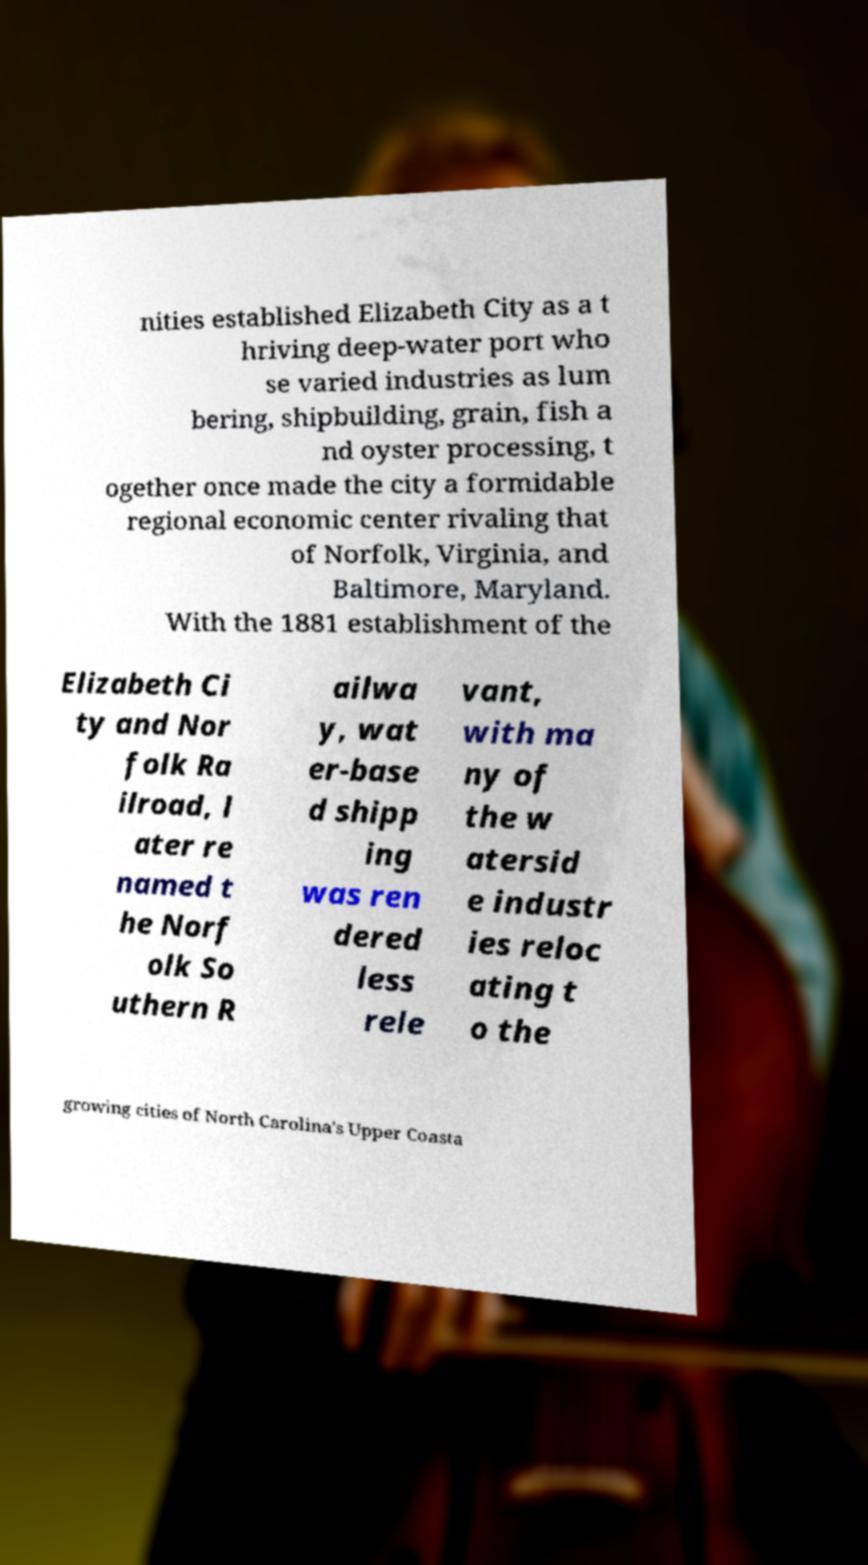Could you assist in decoding the text presented in this image and type it out clearly? nities established Elizabeth City as a t hriving deep-water port who se varied industries as lum bering, shipbuilding, grain, fish a nd oyster processing, t ogether once made the city a formidable regional economic center rivaling that of Norfolk, Virginia, and Baltimore, Maryland. With the 1881 establishment of the Elizabeth Ci ty and Nor folk Ra ilroad, l ater re named t he Norf olk So uthern R ailwa y, wat er-base d shipp ing was ren dered less rele vant, with ma ny of the w atersid e industr ies reloc ating t o the growing cities of North Carolina's Upper Coasta 